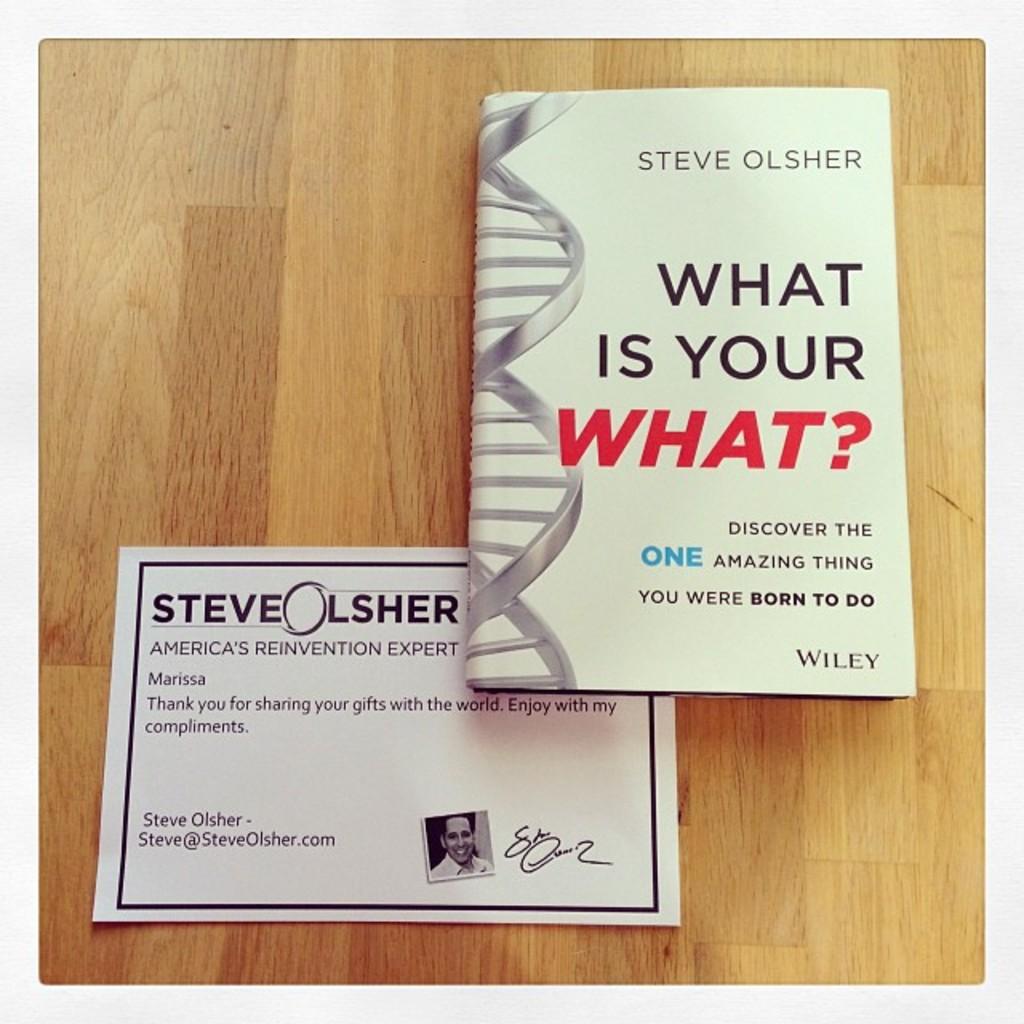Who did steve write the letter to?
Your answer should be very brief. Marissa. What is the title of the book steve olsher wrote?
Offer a terse response. What is your what?. 